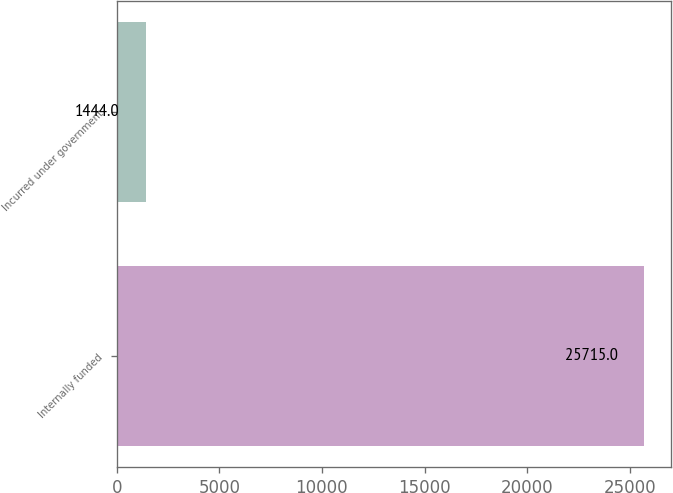Convert chart to OTSL. <chart><loc_0><loc_0><loc_500><loc_500><bar_chart><fcel>Internally funded<fcel>Incurred under government<nl><fcel>25715<fcel>1444<nl></chart> 